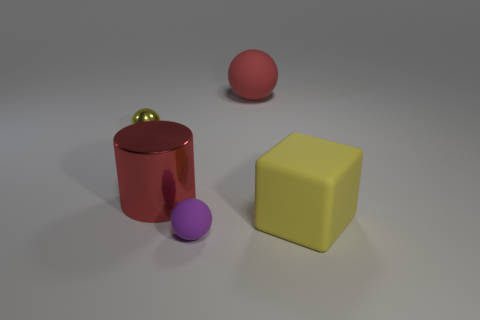Is the number of purple rubber objects that are behind the tiny purple matte object greater than the number of small rubber spheres?
Your response must be concise. No. What size is the red object that is made of the same material as the tiny yellow object?
Your response must be concise. Large. There is a small purple matte thing; are there any big objects on the right side of it?
Provide a succinct answer. Yes. Do the purple object and the tiny metal thing have the same shape?
Your response must be concise. Yes. What size is the matte thing behind the yellow thing right of the large object that is behind the metallic ball?
Ensure brevity in your answer.  Large. What material is the red ball?
Offer a very short reply. Rubber. What is the size of the matte block that is the same color as the metallic ball?
Keep it short and to the point. Large. There is a large yellow thing; does it have the same shape as the red thing that is in front of the big ball?
Keep it short and to the point. No. There is a large thing in front of the cylinder that is on the left side of the yellow thing that is right of the shiny cylinder; what is its material?
Provide a succinct answer. Rubber. What number of small matte balls are there?
Your answer should be very brief. 1. 